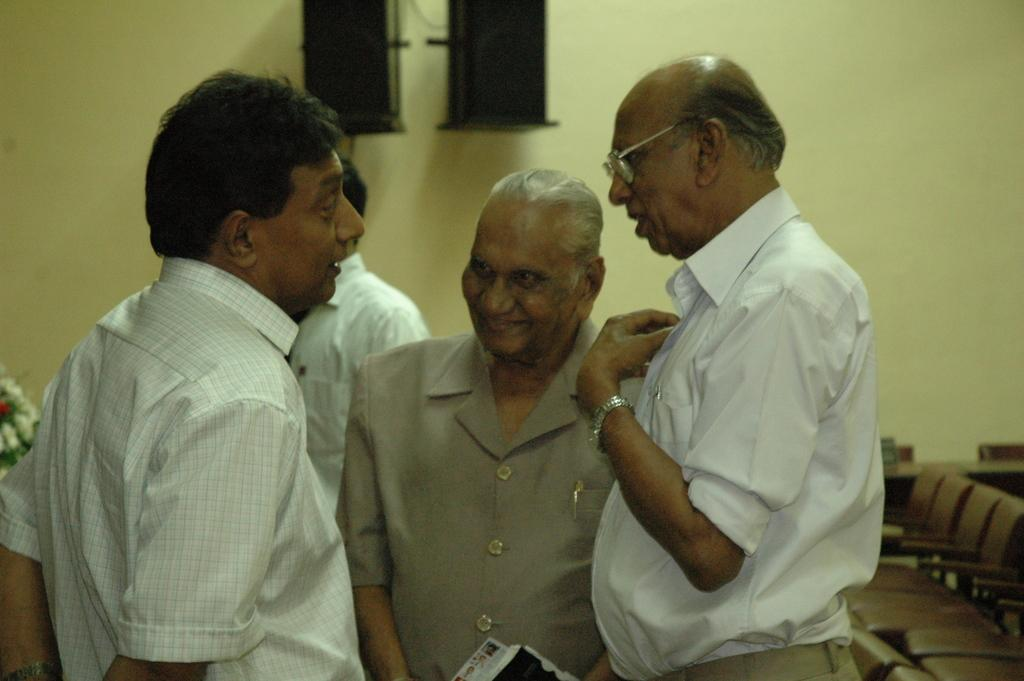What can be seen in the image involving people? There are people standing in the image. What is attached to the wall in the image? There are speakers on the wall in the image. What is located on the left side of the image? There appears to be a flower vase on the left side of the image. What object is being held by a person in the image? A book is held by a person in the image. What type of butter is being spread on the speakers in the image? There is no butter present in the image, nor is any butter being spread on the speakers. Can you see any mist in the image? There is no mist visible in the image. 